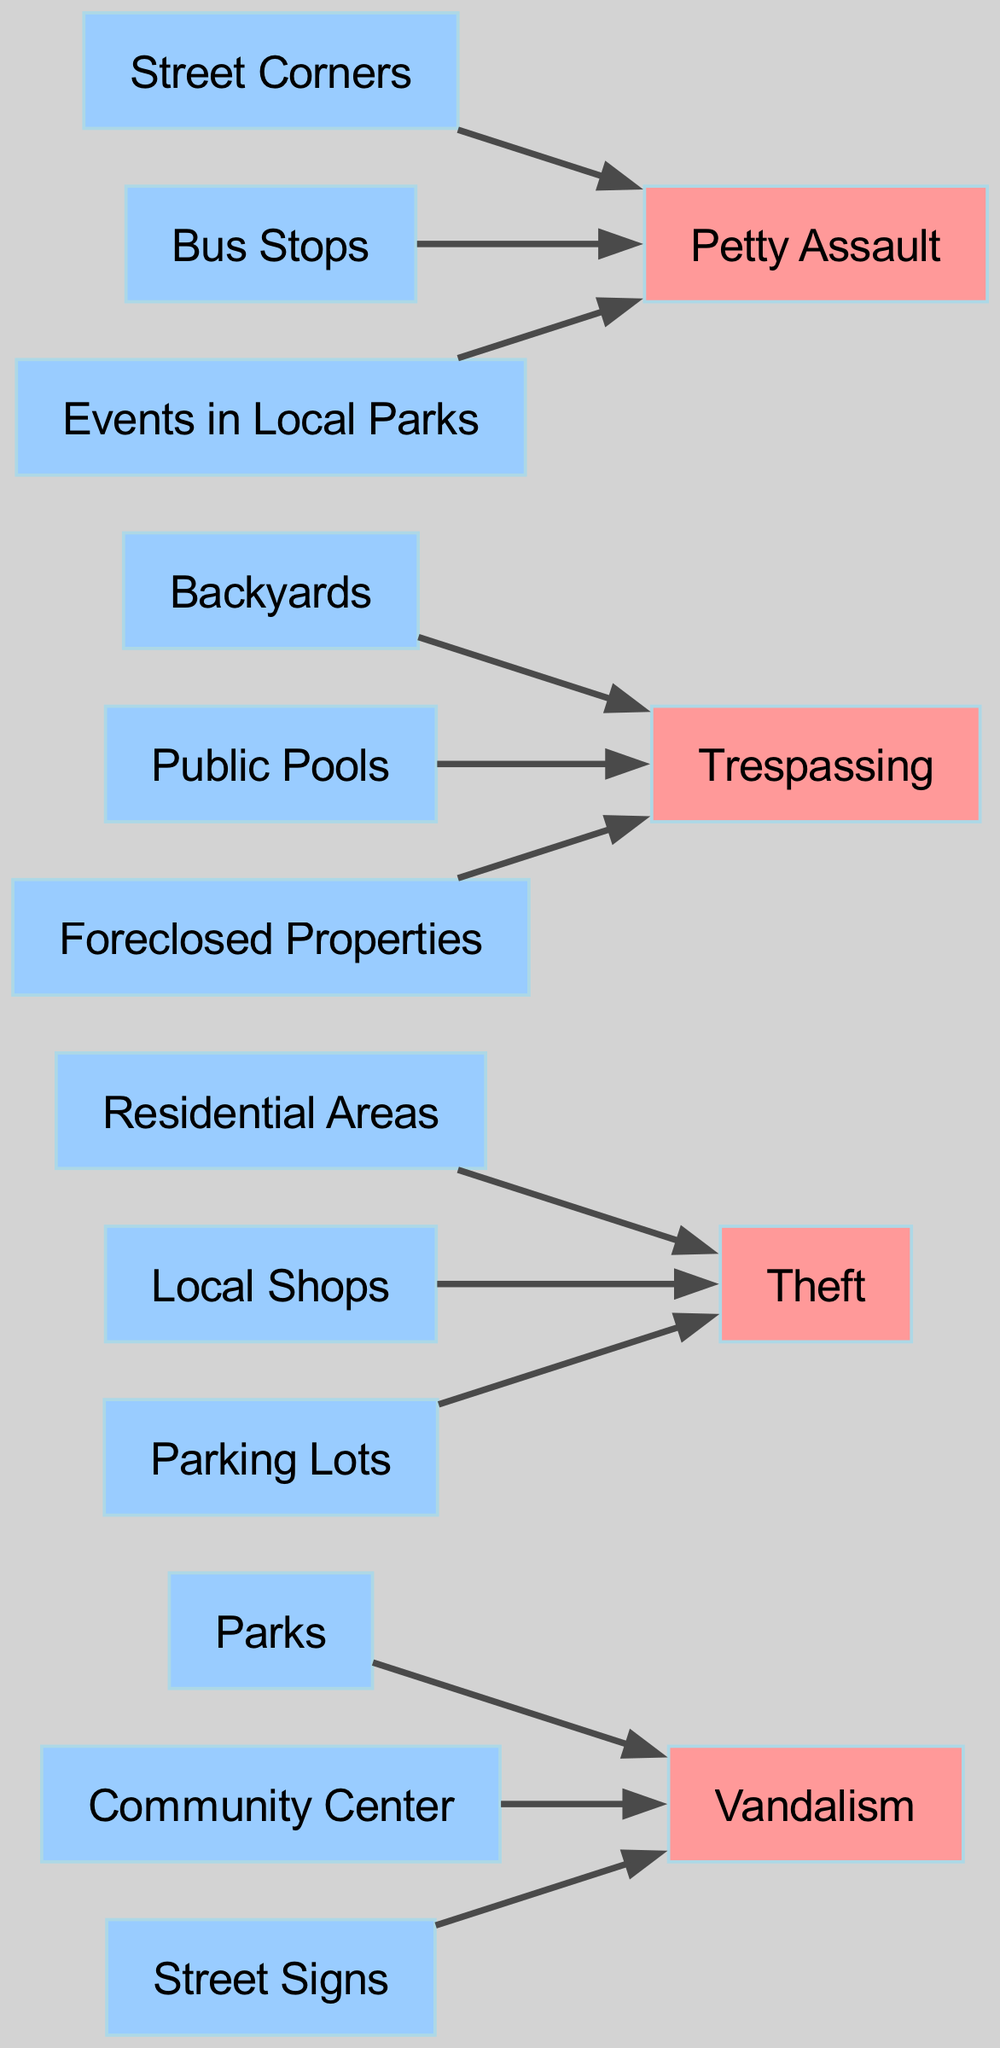What are the sources of vandalism incidents? The sources of vandalism incidents are listed as Parks, Community Center, and Street Signs. I can directly identify these sources connected to the vandalism node in the diagram.
Answer: Parks, Community Center, Street Signs How many types of crimes are represented in the diagram? The diagram features four distinct types of crimes: Vandalism, Theft, Trespassing, and Petty Assault. A simple count of the crime nodes gives the total number of types.
Answer: 4 Which type of crime has the most sources? Theft has the most sources with three connections: Residential Areas, Local Shops, and Parking Lots. Comparing each crime type's source connections, Theft shows the most.
Answer: Theft What is the source of the petty assault incidents? Petty assault incidents originate from Street Corners, Bus Stops, and Events in Local Parks. I can track these sources leading into the Petty Assault node.
Answer: Street Corners, Bus Stops, Events in Local Parks Which crime type is sourced from residential areas? The crime type sourced from Residential Areas is Theft. I can observe a direct connection between Residential Areas and the Theft node in the diagram.
Answer: Theft Are there any crime types connected to public pools? Yes, Trespassing is connected to Public Pools as one of its sources. I can see Public Pools leading into the Trespassing node.
Answer: Yes How many sources are listed for trespassing incidents? Trespassing has three sources: Backyards, Public Pools, and Foreclosed Properties. I can count these connections leading to the Trespassing node.
Answer: 3 Which sources contribute to the vandalism crime type in the diagram? The sources contributing to vandalism are Parks, Community Center, and Street Signs. These sources are visually shown as connecting to the Vandalism node.
Answer: Parks, Community Center, Street Signs What types of crime are sourced from street corners? Petty Assault is the only crime type sourced from Street Corners. I notice that Street Corners flows directly to the Petty Assault node.
Answer: Petty Assault 